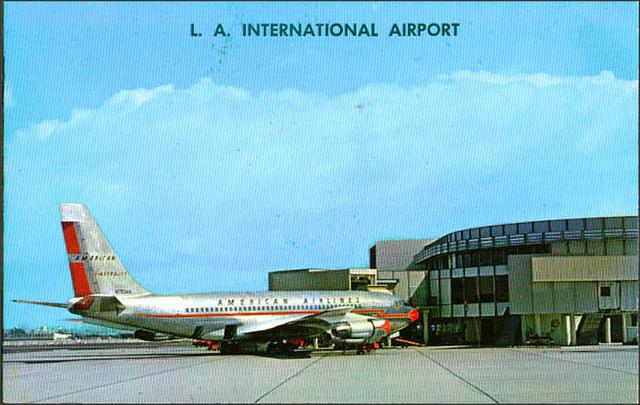What airport is this?
Be succinct. La international airport. Is this a recent photograph?
Be succinct. No. What is the weather like here?
Keep it brief. Sunny. What airline's plane is in the photo?
Be succinct. American airlines. What airline is on the plane?
Write a very short answer. American airlines. Is the sun shining?
Keep it brief. Yes. 